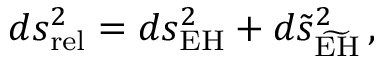<formula> <loc_0><loc_0><loc_500><loc_500>d s _ { r e l } ^ { 2 } = d s _ { E H } ^ { 2 } + d \tilde { s } _ { \widetilde { E H } } ^ { 2 } \, ,</formula> 